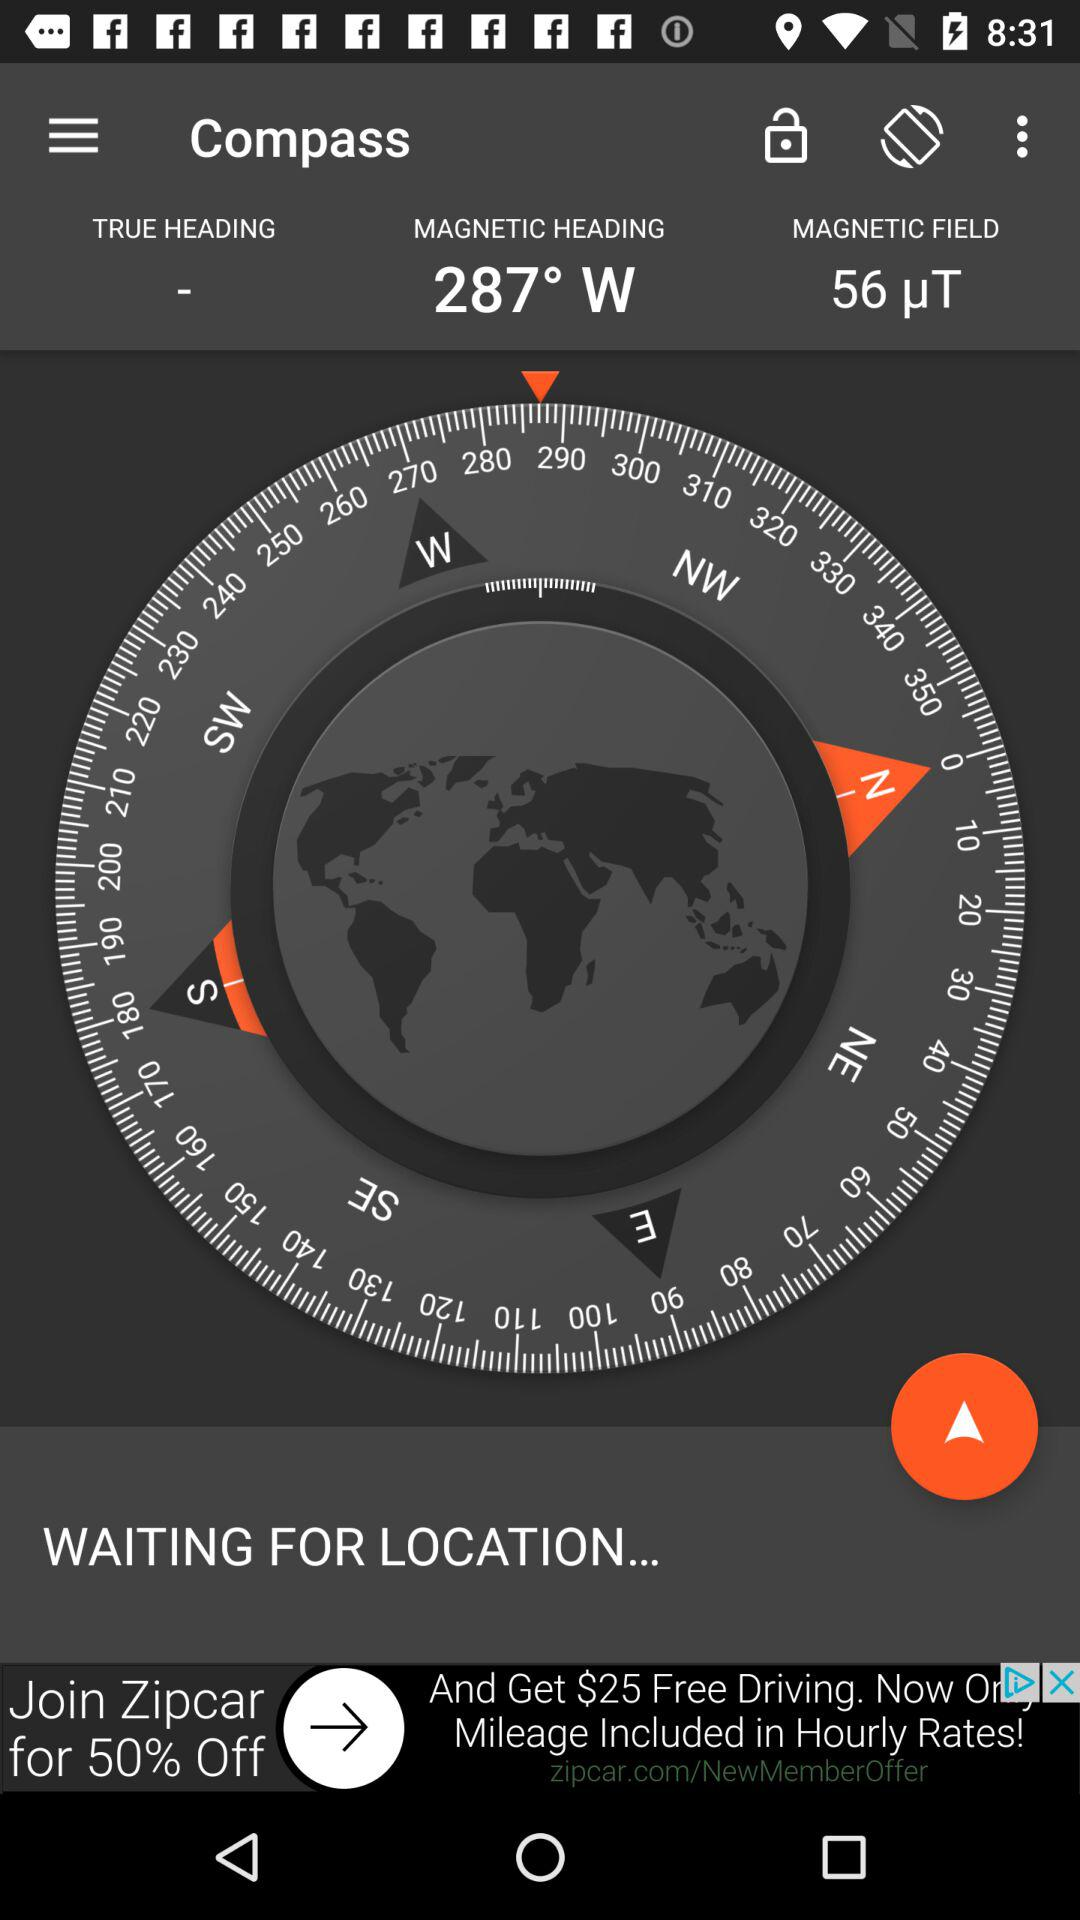Which location is selected?
When the provided information is insufficient, respond with <no answer>. <no answer> 